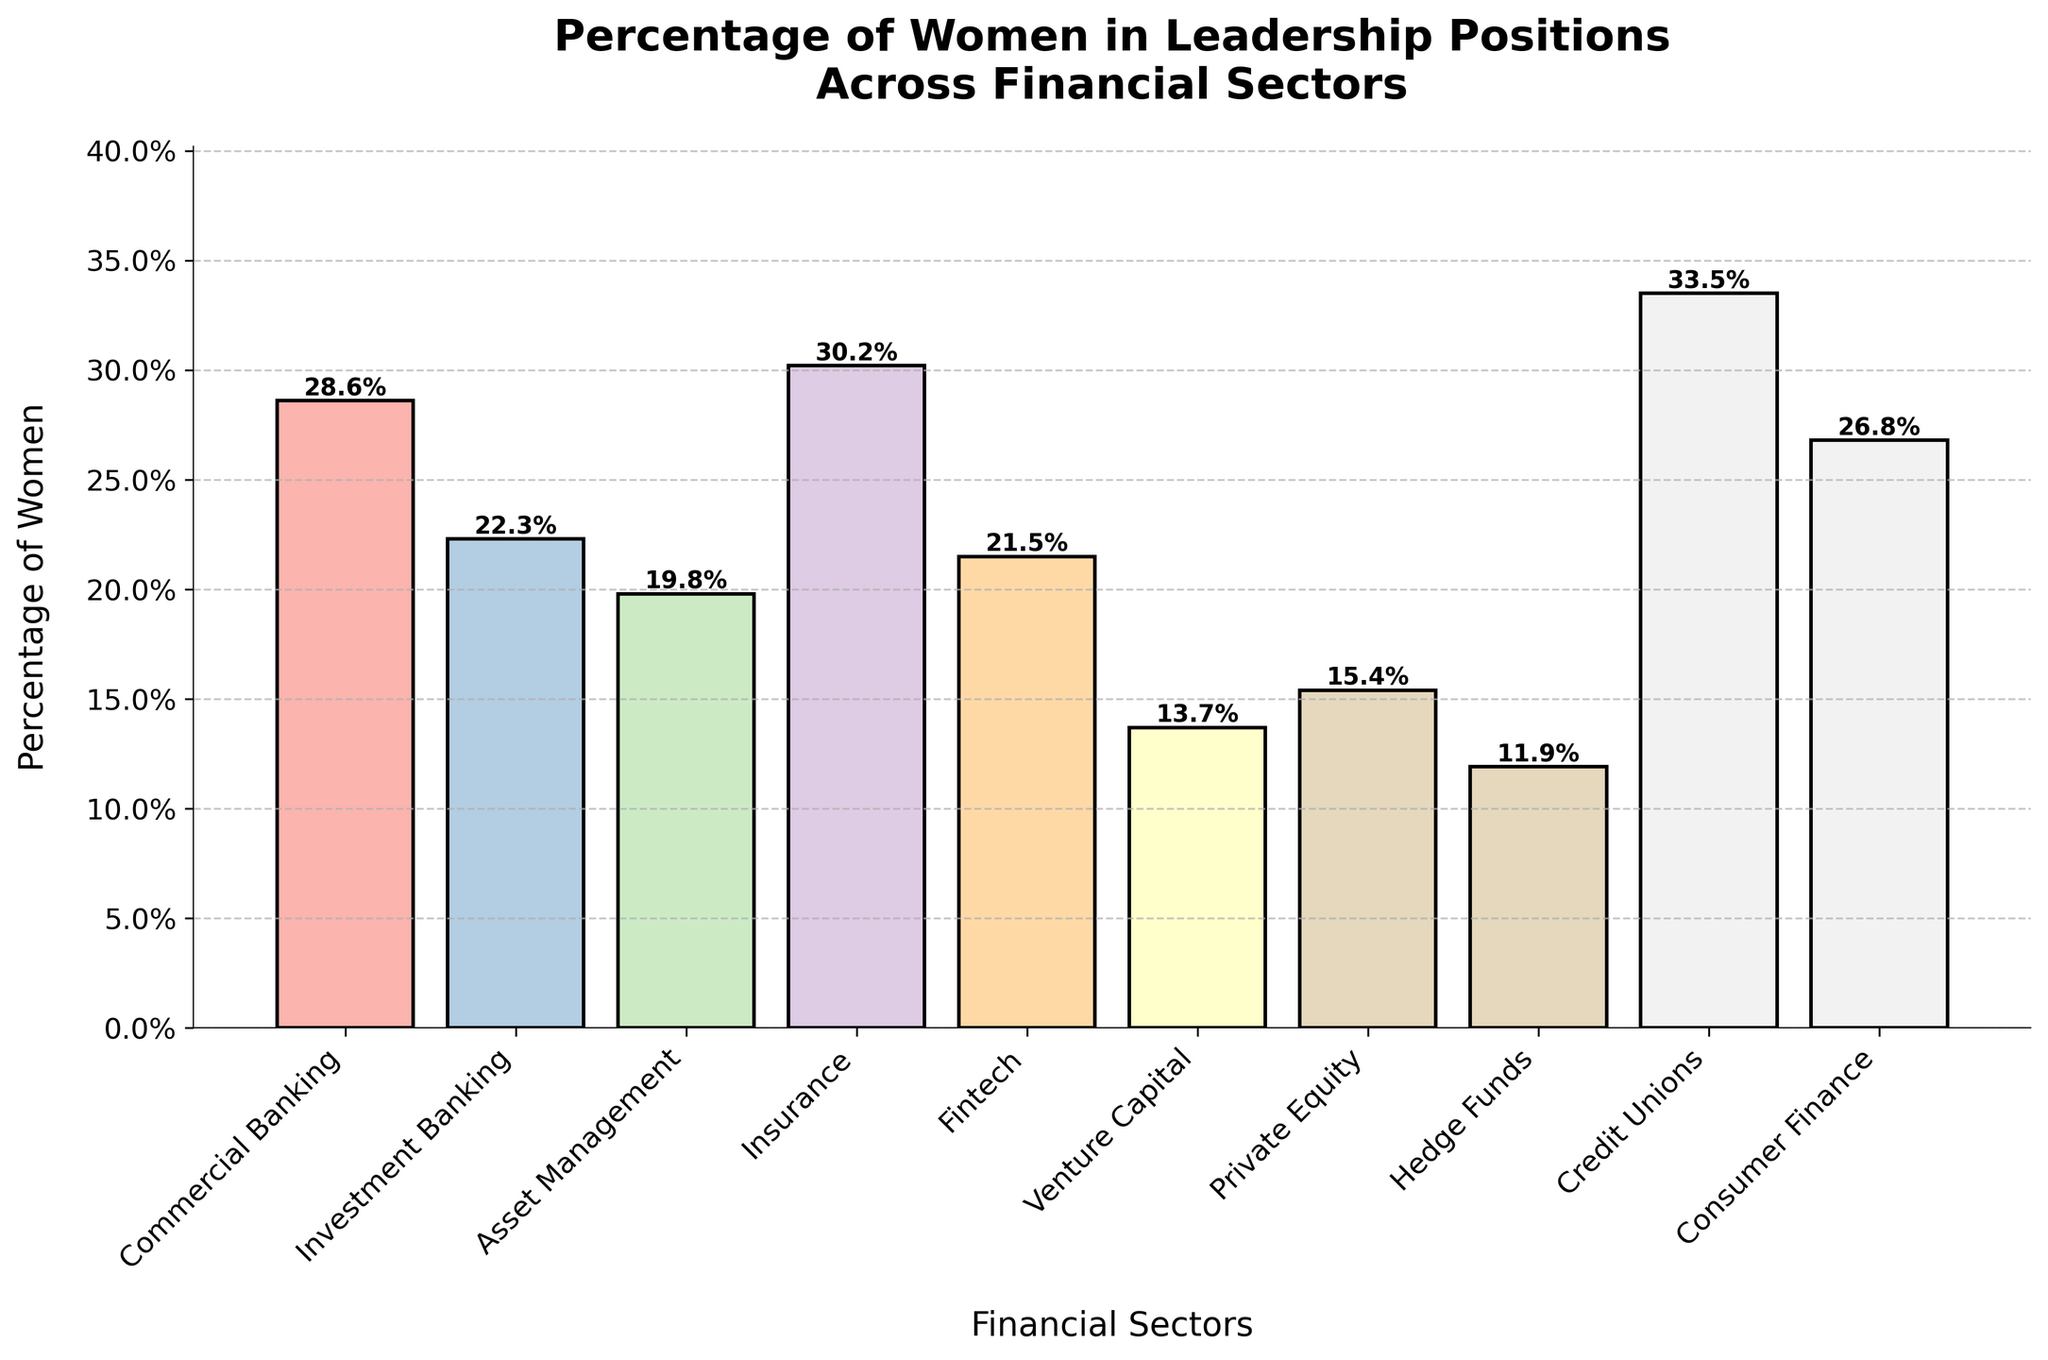What sector has the highest percentage of women in leadership positions? Observe the heights of the bars to find the tallest one, which represents the sector with the highest percentage. The tallest bar is for Credit Unions.
Answer: Credit Unions Which sector has the lowest percentage of women in leadership positions? Observe the heights of the bars to find the shortest one, which represents the sector with the lowest percentage. The shortest bar is for Hedge Funds.
Answer: Hedge Funds What is the difference in the percentage of women in leadership between Insurance and Private Equity? Locate the bars for Insurance and Private Equity, note their heights (30.2% and 15.4% respectively), then subtract the smaller percentage from the larger. The difference is 30.2% - 15.4% = 14.8%.
Answer: 14.8% Which sectors have a percentage of women in leadership greater than 25%? Identify the bars that extend above the 25% mark. These include Commercial Banking, Insurance, Credit Unions, and Consumer Finance.
Answer: Commercial Banking, Insurance, Credit Unions, Consumer Finance Which has a higher percentage of women in leadership: Fintech or Asset Management? Compare the heights of the bars for Fintech and Asset Management. Fintech has 21.5% and Asset Management has 19.8%. Therefore, Fintech has a higher percentage.
Answer: Fintech What is the average percentage of women in leadership in the financial sectors listed? Sum all the percentages: (28.6 + 22.3 + 19.8 + 30.2 + 21.5 + 13.7 + 15.4 + 11.9 + 33.5 + 26.8) = 223.7, then divide by the number of sectors (10). The average is 223.7 / 10 = 22.37%.
Answer: 22.37% What is the total percentage of women in leadership for Commercial Banking, Investment Banking, and Insurance combined? Add the percentages for Commercial Banking (28.6%), Investment Banking (22.3%), and Insurance (30.2%). The total is 28.6 + 22.3 + 30.2 = 81.1%.
Answer: 81.1% Are there more sectors with a percentage of women in leadership below or above 20%? Count the number of bars below and above the 20% mark. There are 4 sectors below 20% (Asset Management, Venture Capital, Private Equity, Hedge Funds) and 6 sectors above 20% (Commercial Banking, Investment Banking, Insurance, Fintech, Credit Unions, Consumer Finance). There are more sectors above 20%.
Answer: Above 20% Which sector's bar is closest in height to Consumer Finance? Compare the heights of the bars and find the one closest to 26.8%. Commercial Banking is closest with 28.6%.
Answer: Commercial Banking 